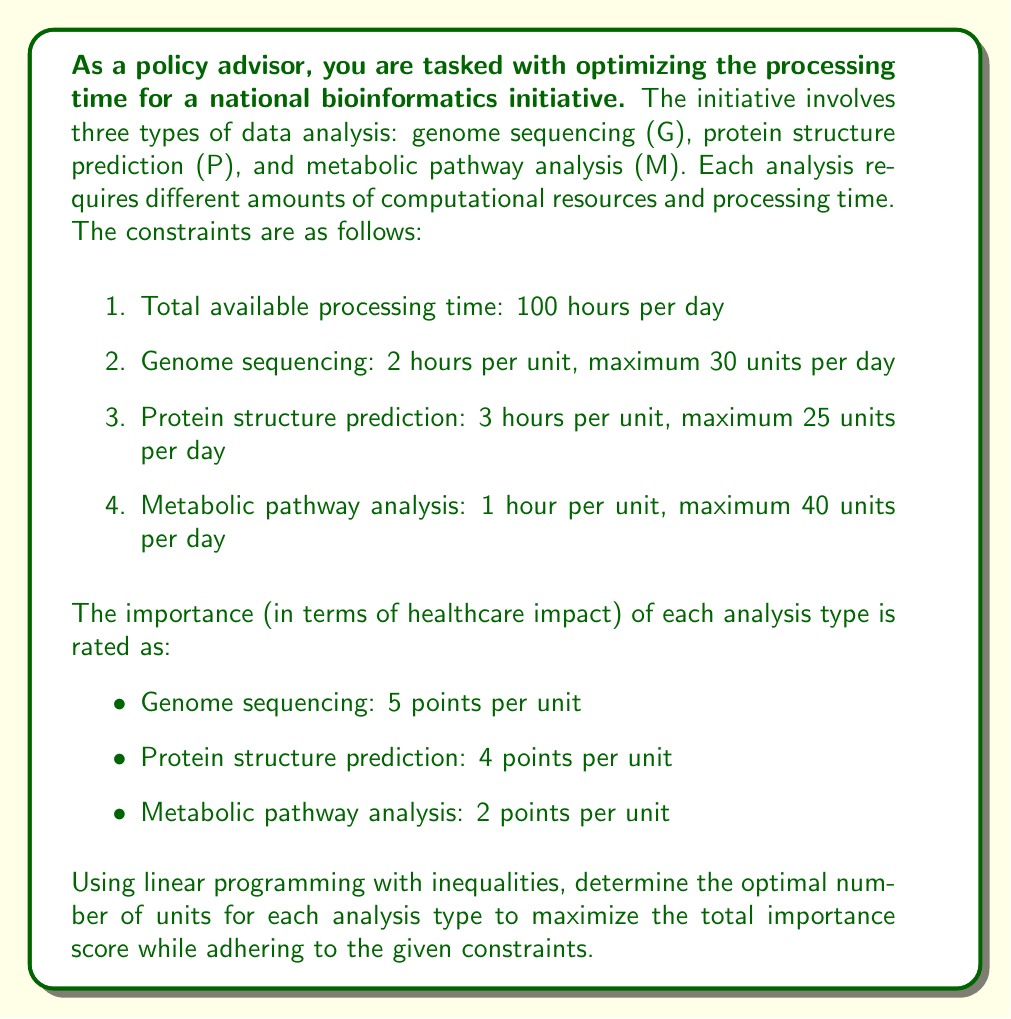What is the answer to this math problem? To solve this linear programming problem, we'll follow these steps:

1. Define variables:
Let $x$ = units of genome sequencing
Let $y$ = units of protein structure prediction
Let $z$ = units of metabolic pathway analysis

2. Set up the objective function to maximize:
$$ \text{Maximize: } 5x + 4y + 2z $$

3. Define the constraints as inequalities:
a. Total processing time: $2x + 3y + z \leq 100$
b. Maximum units for genome sequencing: $x \leq 30$
c. Maximum units for protein structure prediction: $y \leq 25$
d. Maximum units for metabolic pathway analysis: $z \leq 40$
e. Non-negativity constraints: $x \geq 0, y \geq 0, z \geq 0$

4. Solve the linear programming problem:
We can solve this using the simplex method or graphical method. In this case, we'll use reasoning to find the optimal solution:

- Genome sequencing has the highest importance per unit (5 points) and uses 2 hours per unit. We should maximize this first.
- Protein structure prediction has the second-highest importance (4 points) and uses 3 hours per unit.
- Metabolic pathway analysis has the lowest importance (2 points) and uses 1 hour per unit.

Let's allocate resources in order of importance:

a. Genome sequencing: 30 units (maximum allowed)
   Time used: $30 \times 2 = 60$ hours
   Remaining time: $100 - 60 = 40$ hours

b. Protein structure prediction:
   We can allocate $40 \div 3 = 13.33$ units, but we're limited to whole numbers.
   So, we'll allocate 13 units.
   Time used: $13 \times 3 = 39$ hours
   Remaining time: $40 - 39 = 1$ hour

c. Metabolic pathway analysis:
   We can use the remaining 1 hour for 1 unit of this analysis.

5. Check if the solution satisfies all constraints:
   - Total time: $60 + 39 + 1 = 100$ hours (constraint satisfied)
   - All maximum unit constraints are satisfied
   - All variables are non-negative

6. Calculate the maximum importance score:
   $5(30) + 4(13) + 2(1) = 150 + 52 + 2 = 204$
Answer: The optimal solution is:
- Genome sequencing (G): 30 units
- Protein structure prediction (P): 13 units
- Metabolic pathway analysis (M): 1 unit

Maximum importance score: 204 points 